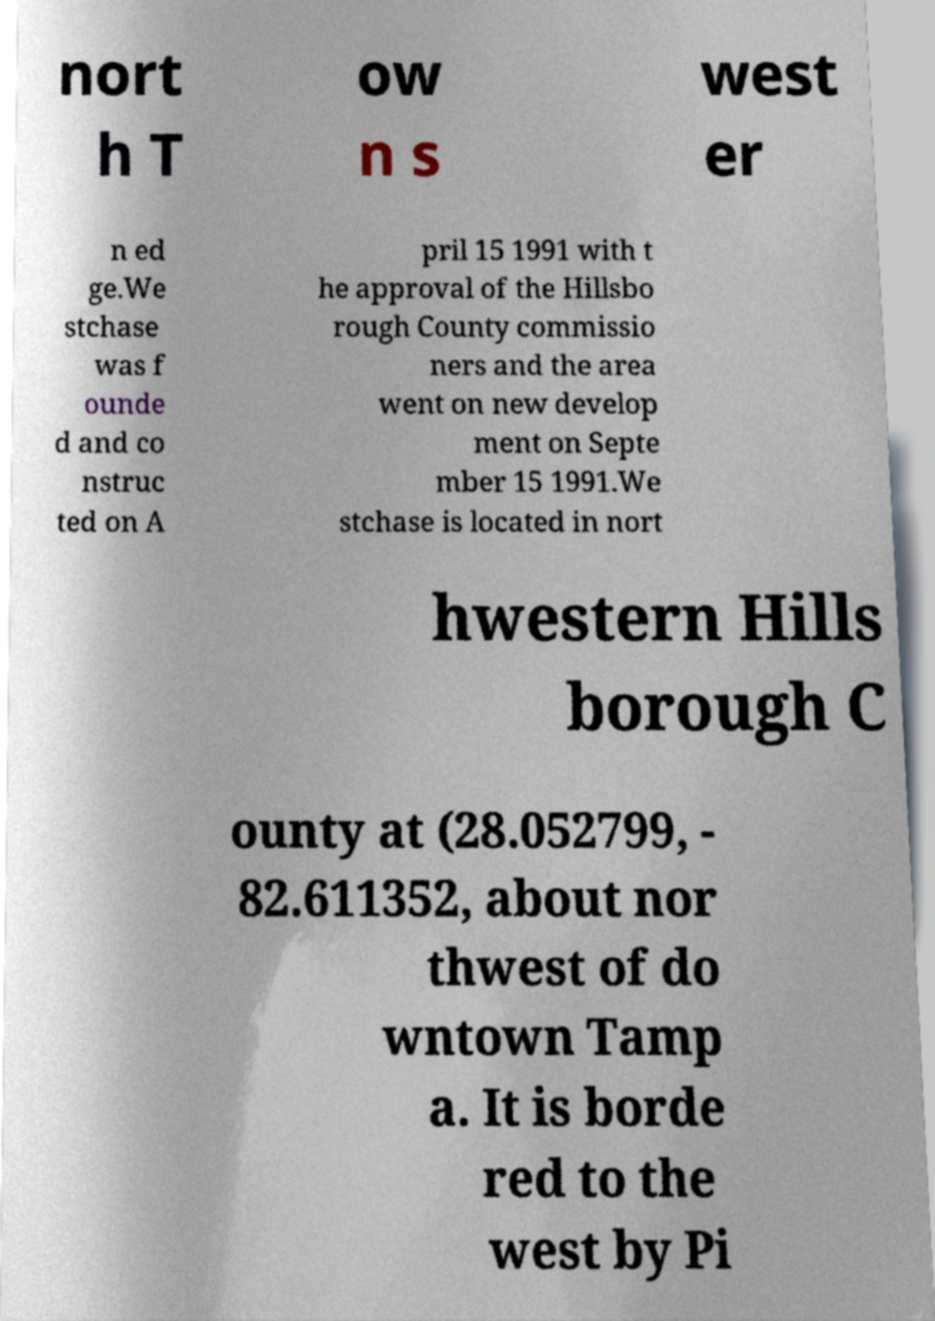Can you accurately transcribe the text from the provided image for me? nort h T ow n s west er n ed ge.We stchase was f ounde d and co nstruc ted on A pril 15 1991 with t he approval of the Hillsbo rough County commissio ners and the area went on new develop ment on Septe mber 15 1991.We stchase is located in nort hwestern Hills borough C ounty at (28.052799, - 82.611352, about nor thwest of do wntown Tamp a. It is borde red to the west by Pi 